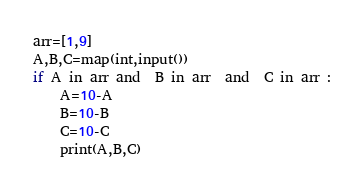Convert code to text. <code><loc_0><loc_0><loc_500><loc_500><_Python_>arr=[1,9]
A,B,C=map(int,input())
if A in arr and  B in arr  and  C in arr :
    A=10-A
    B=10-B
    C=10-C
    print(A,B,C)
</code> 